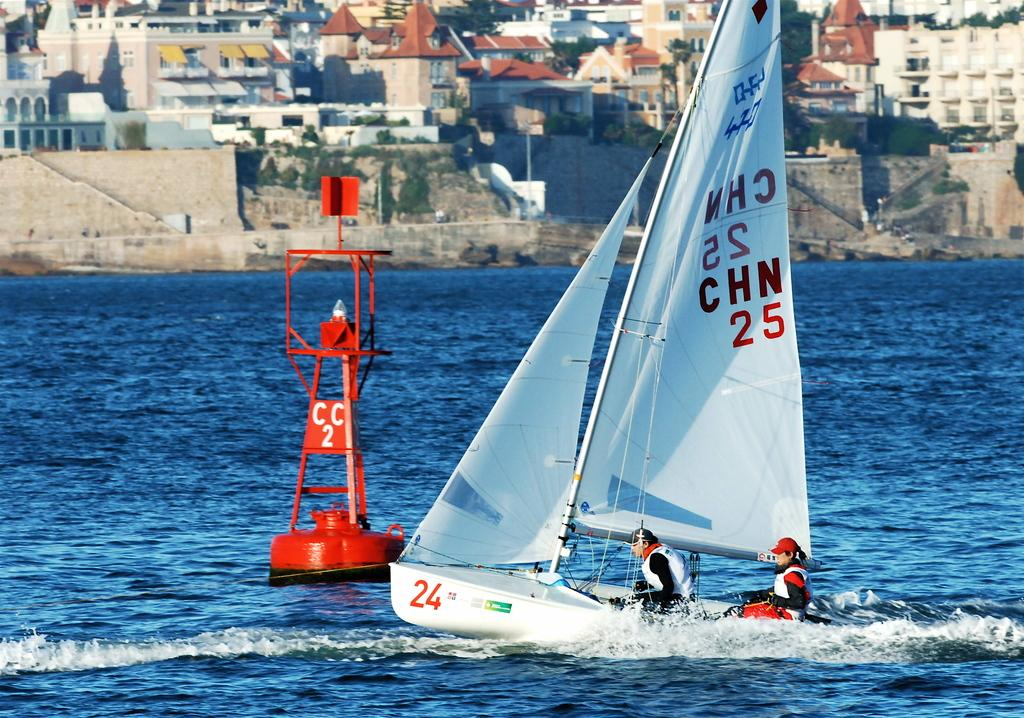What is the main subject of the image? The main subject of the image is a group of persons in a boat. Where is the boat located? The boat is placed in the water. What can be seen in the background of the image? There is a red-colored pole and buildings in the background, along with water. What type of creature is swimming alongside the boat in the image? There is no creature swimming alongside the boat in the image; it only shows a group of persons in a boat. 